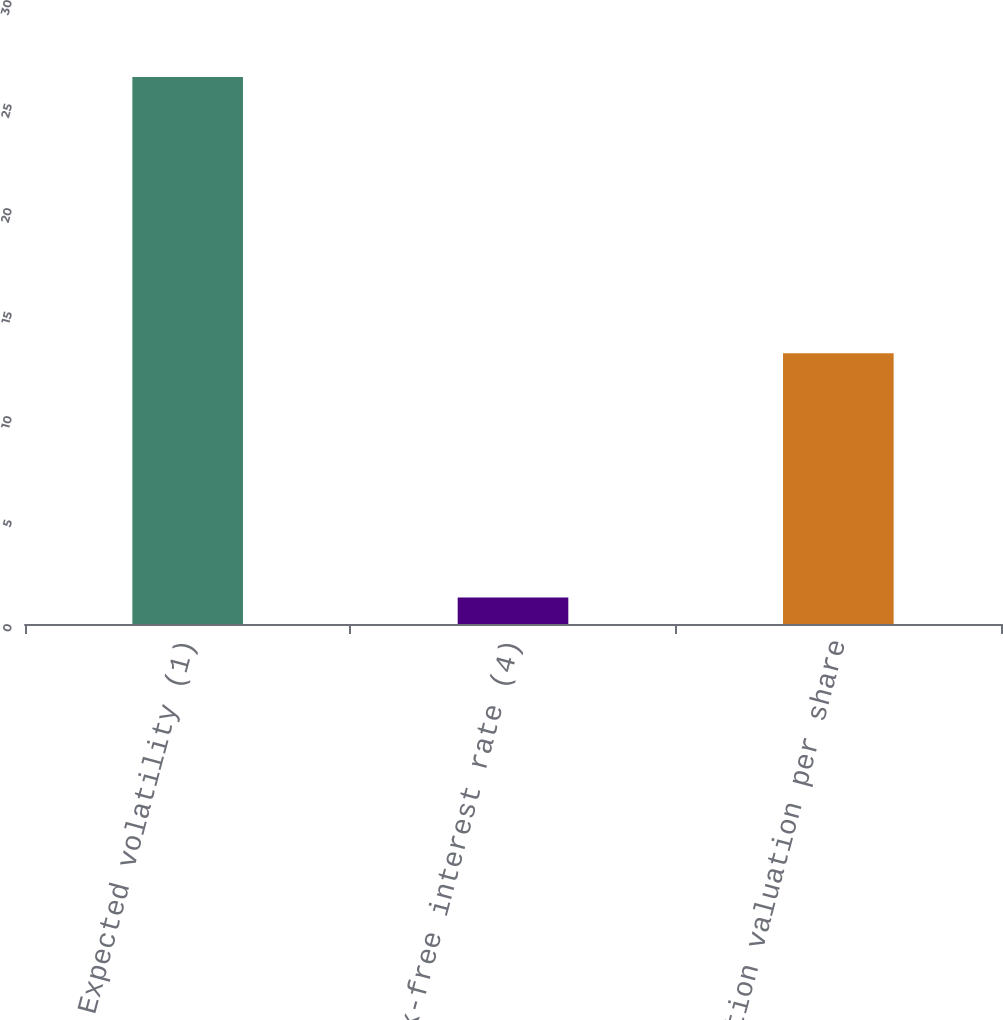Convert chart to OTSL. <chart><loc_0><loc_0><loc_500><loc_500><bar_chart><fcel>Expected volatility (1)<fcel>Risk-free interest rate (4)<fcel>Option valuation per share<nl><fcel>26.3<fcel>1.27<fcel>13.02<nl></chart> 